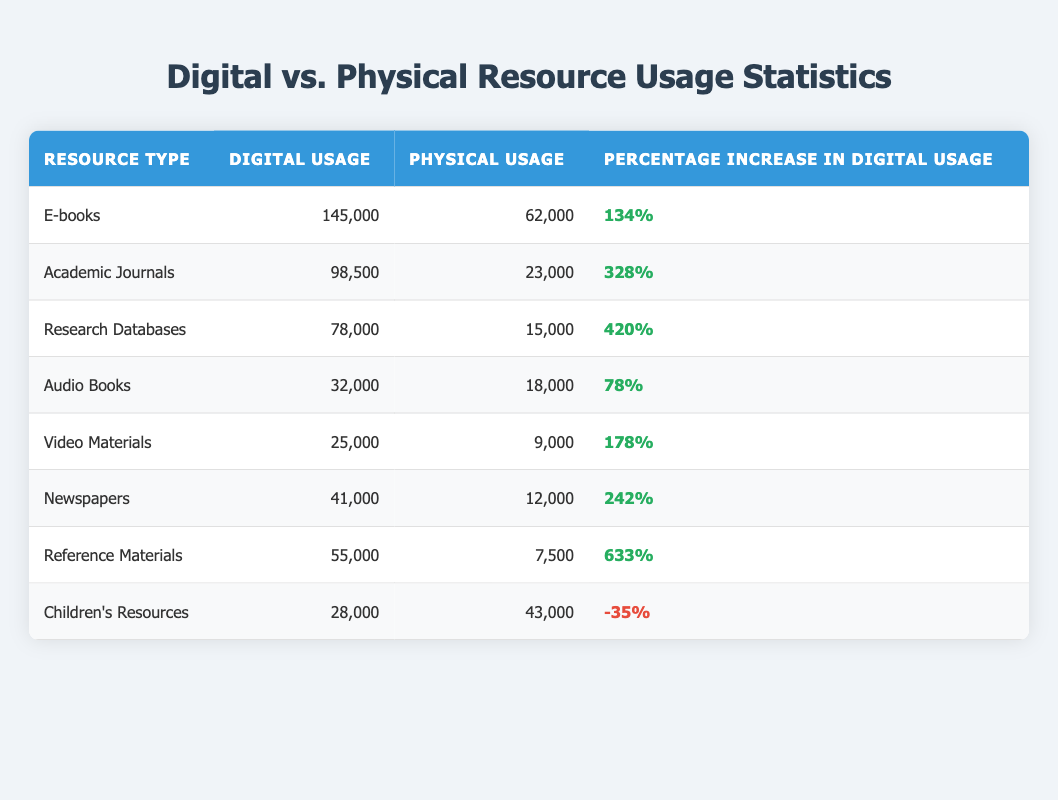What is the digital usage of Academic Journals? The table shows the column for Digital Usage next to Academic Journals, and it lists the value as 98,500.
Answer: 98,500 Which resource type had the highest percentage increase in digital usage? By comparing the "Percentage Increase in Digital Usage" column, Research Databases shows the highest increment at 420%, making it the resource with the highest growth in digital usage.
Answer: Research Databases What is the total digital usage for E-books and Video Materials combined? The digital usage for E-books is 145,000 and for Video Materials is 25,000. Adding these two amounts gives us 145,000 + 25,000 = 170,000.
Answer: 170,000 Is the physical usage of Children's Resources greater than that of Audio Books? From the table, the physical usage of Children's Resources is 43,000, and for Audio Books, it is 18,000. Since 43,000 is greater than 18,000, the statement is true.
Answer: Yes What is the average percentage increase in digital usage across all resources listed in the table? We first calculate the total percentage increase by converting each percentage into a numerical form: 134 + 328 + 420 + 78 + 178 + 242 + 633 - 35 = 1977. Then we divide this by the total number of resource types, which is 8. So, 1977 / 8 = 247.125, rounded to 247%.
Answer: 247% Which type of resource had the lowest digital usage? The lowest value in the Digital Usage column can be found by scanning through the listed numbers. It shows 25,000 for Video Materials, which is lower than all other categories.
Answer: Video Materials Was the digital usage of Reference Materials greater than that of all other types? Looking at the Digital Usage column, Reference Materials had 55,000, which is exceeded by E-books (145,000) and Academic Journals (98,500), thus the statement is false.
Answer: No How does the digital usage of Newspapers compare to that of E-books? The digital usage for Newspapers is 41,000, and for E-books, it is 145,000. Since 41,000 is less than 145,000, that indicates Newspapers have lower digital usage than E-books.
Answer: Newspapers have lower digital usage 